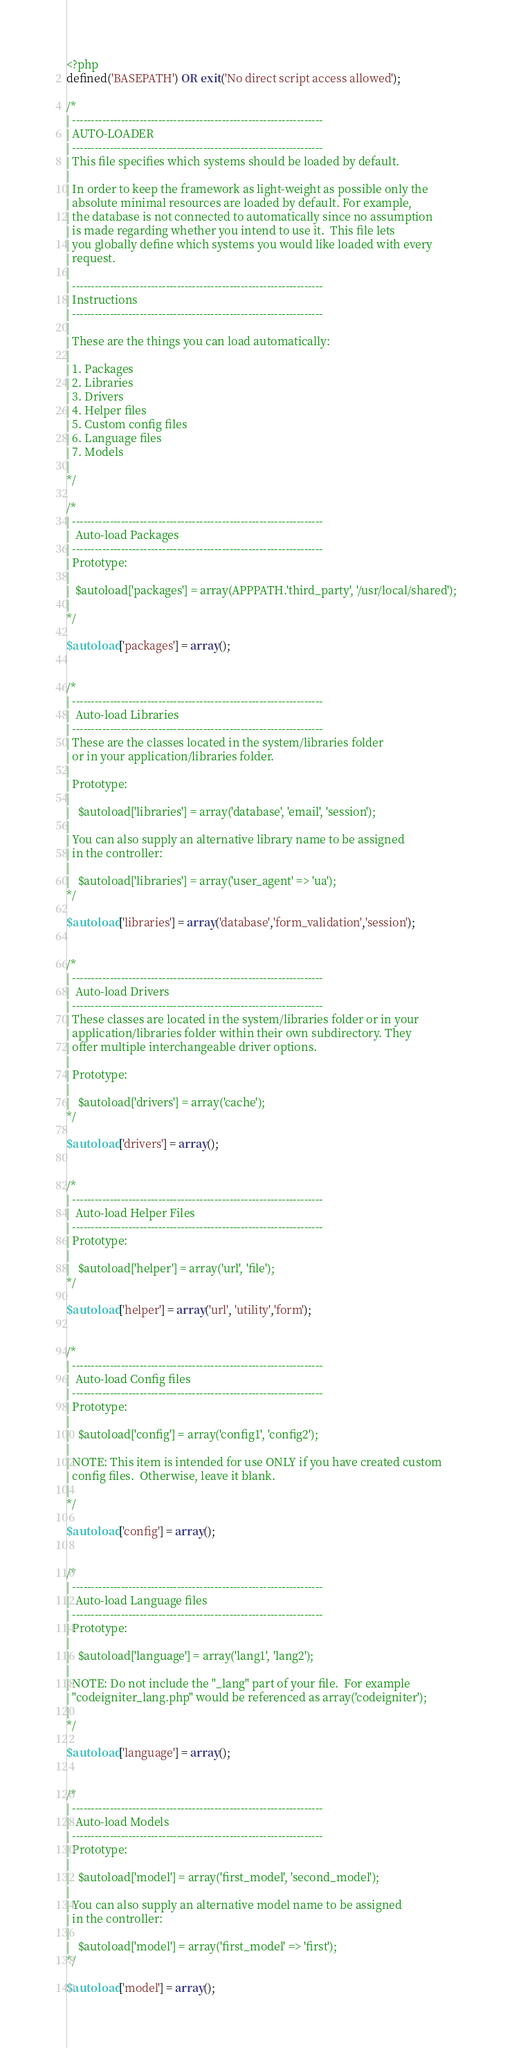Convert code to text. <code><loc_0><loc_0><loc_500><loc_500><_PHP_><?php
defined('BASEPATH') OR exit('No direct script access allowed');

/*
| -------------------------------------------------------------------
| AUTO-LOADER
| -------------------------------------------------------------------
| This file specifies which systems should be loaded by default.
|
| In order to keep the framework as light-weight as possible only the
| absolute minimal resources are loaded by default. For example,
| the database is not connected to automatically since no assumption
| is made regarding whether you intend to use it.  This file lets
| you globally define which systems you would like loaded with every
| request.
|
| -------------------------------------------------------------------
| Instructions
| -------------------------------------------------------------------
|
| These are the things you can load automatically:
|
| 1. Packages
| 2. Libraries
| 3. Drivers
| 4. Helper files
| 5. Custom config files
| 6. Language files
| 7. Models
|
*/

/*
| -------------------------------------------------------------------
|  Auto-load Packages
| -------------------------------------------------------------------
| Prototype:
|
|  $autoload['packages'] = array(APPPATH.'third_party', '/usr/local/shared');
|
*/

$autoload['packages'] = array();


/*
| -------------------------------------------------------------------
|  Auto-load Libraries
| -------------------------------------------------------------------
| These are the classes located in the system/libraries folder
| or in your application/libraries folder.
|
| Prototype:
|
|	$autoload['libraries'] = array('database', 'email', 'session');
|
| You can also supply an alternative library name to be assigned
| in the controller:
|
|	$autoload['libraries'] = array('user_agent' => 'ua');
*/

$autoload['libraries'] = array('database','form_validation','session');


/*
| -------------------------------------------------------------------
|  Auto-load Drivers
| -------------------------------------------------------------------
| These classes are located in the system/libraries folder or in your
| application/libraries folder within their own subdirectory. They
| offer multiple interchangeable driver options.
|
| Prototype:
|
|	$autoload['drivers'] = array('cache');
*/

$autoload['drivers'] = array();


/*
| -------------------------------------------------------------------
|  Auto-load Helper Files
| -------------------------------------------------------------------
| Prototype:
|
|	$autoload['helper'] = array('url', 'file');
*/

$autoload['helper'] = array('url', 'utility','form');


/*
| -------------------------------------------------------------------
|  Auto-load Config files
| -------------------------------------------------------------------
| Prototype:
|
|	$autoload['config'] = array('config1', 'config2');
|
| NOTE: This item is intended for use ONLY if you have created custom
| config files.  Otherwise, leave it blank.
|
*/

$autoload['config'] = array();


/*
| -------------------------------------------------------------------
|  Auto-load Language files
| -------------------------------------------------------------------
| Prototype:
|
|	$autoload['language'] = array('lang1', 'lang2');
|
| NOTE: Do not include the "_lang" part of your file.  For example
| "codeigniter_lang.php" would be referenced as array('codeigniter');
|
*/

$autoload['language'] = array();


/*
| -------------------------------------------------------------------
|  Auto-load Models
| -------------------------------------------------------------------
| Prototype:
|
|	$autoload['model'] = array('first_model', 'second_model');
|
| You can also supply an alternative model name to be assigned
| in the controller:
|
|	$autoload['model'] = array('first_model' => 'first');
*/

$autoload['model'] = array();
</code> 